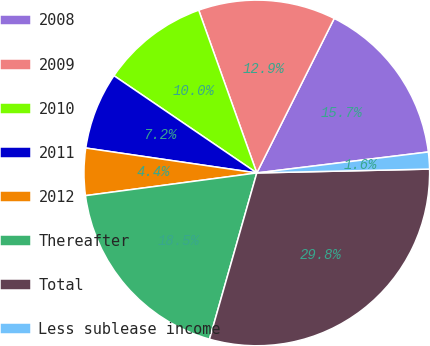<chart> <loc_0><loc_0><loc_500><loc_500><pie_chart><fcel>2008<fcel>2009<fcel>2010<fcel>2011<fcel>2012<fcel>Thereafter<fcel>Total<fcel>Less sublease income<nl><fcel>15.67%<fcel>12.85%<fcel>10.03%<fcel>7.21%<fcel>4.4%<fcel>18.49%<fcel>29.77%<fcel>1.58%<nl></chart> 